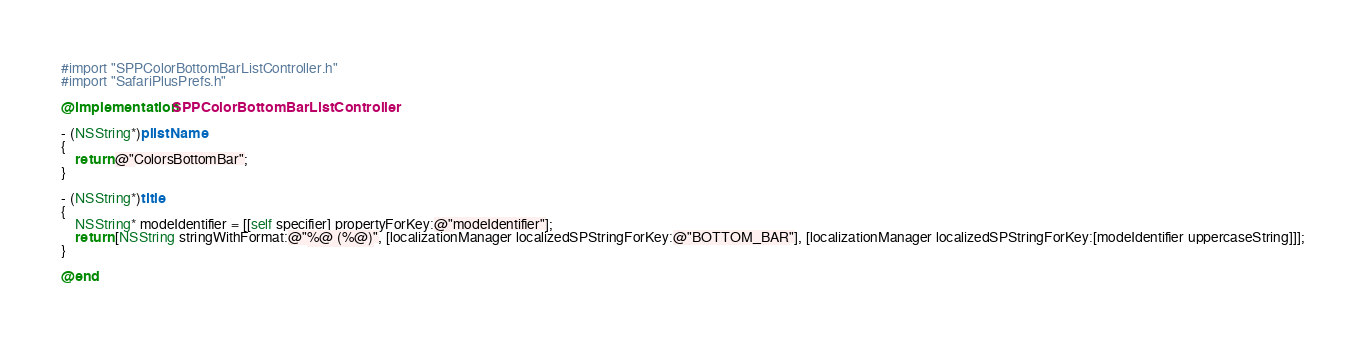Convert code to text. <code><loc_0><loc_0><loc_500><loc_500><_ObjectiveC_>#import "SPPColorBottomBarListController.h"
#import "SafariPlusPrefs.h"

@implementation SPPColorBottomBarListController

- (NSString*)plistName
{
	return @"ColorsBottomBar";
}

- (NSString*)title
{
	NSString* modeIdentifier = [[self specifier] propertyForKey:@"modeIdentifier"];
	return [NSString stringWithFormat:@"%@ (%@)", [localizationManager localizedSPStringForKey:@"BOTTOM_BAR"], [localizationManager localizedSPStringForKey:[modeIdentifier uppercaseString]]];
}

@end
</code> 